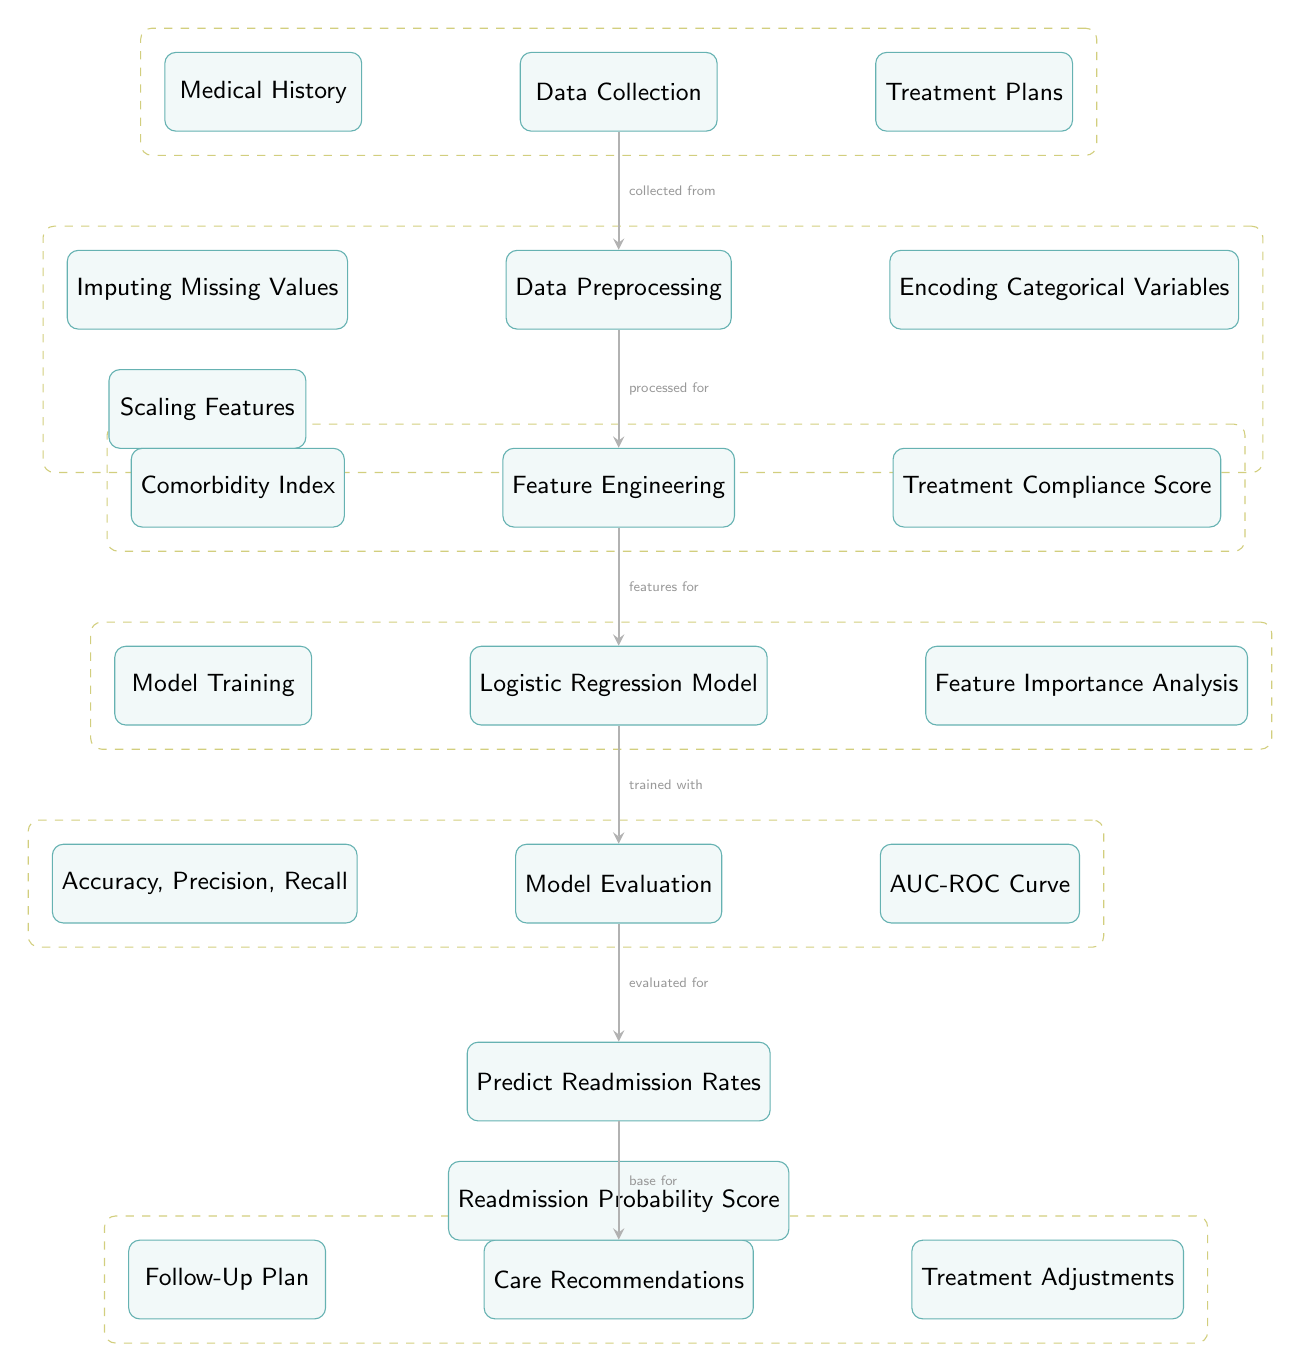What is the first step in the process? The first step in the diagram is "Data Collection," which is shown at the top. It indicates that the process starts with collecting data relevant to the analysis.
Answer: Data Collection How many processes are involved after data preprocessing? After the "Data Preprocessing" step, there are four processes involved, which are "Feature Engineering," "Logistic Regression Model," "Model Evaluation," and "Predict Readmission Rates."
Answer: Four What type of analysis is conducted after the logistic regression? The type of analysis conducted after the logistic regression model is "Feature Importance Analysis," which focuses on understanding how different features contribute to the model’s predictions.
Answer: Feature Importance Analysis What is evaluated to improve care recommendations? "Readmission Rates" are evaluated to improve the care recommendations based on the model’s predictions. This step is crucial to tailor the recommendations effectively.
Answer: Readmission Rates Which component relates to improving treatment adherence? The "Treatment Compliance Score" in the feature engineering step relates to improving treatment adherence by considering patients' compliance as a feature in the model.
Answer: Treatment Compliance Score What are the final outputs proposed in the model? The final outputs proposed in the model are "Follow-Up Plan" and "Treatment Adjustments," which are recommendations based on the predicted readmission probabilities.
Answer: Follow-Up Plan and Treatment Adjustments What process follows model training in the diagram? The process that follows "Model Training" in the diagram is "Feature Importance Analysis," where the importance of various features is assessed after training the model.
Answer: Feature Importance Analysis What do the accuracy, precision, and recall metrics assess? The metrics "Accuracy, Precision, Recall" assess the performance of the logistic regression model during the evaluation step to understand its effectiveness in predicting hospital readmission.
Answer: Performance of the model What step comes before predicting readmission rates? The step that comes before predicting readmission rates is "Model Evaluation," where the model's effectiveness is analyzed before making predictions.
Answer: Model Evaluation 